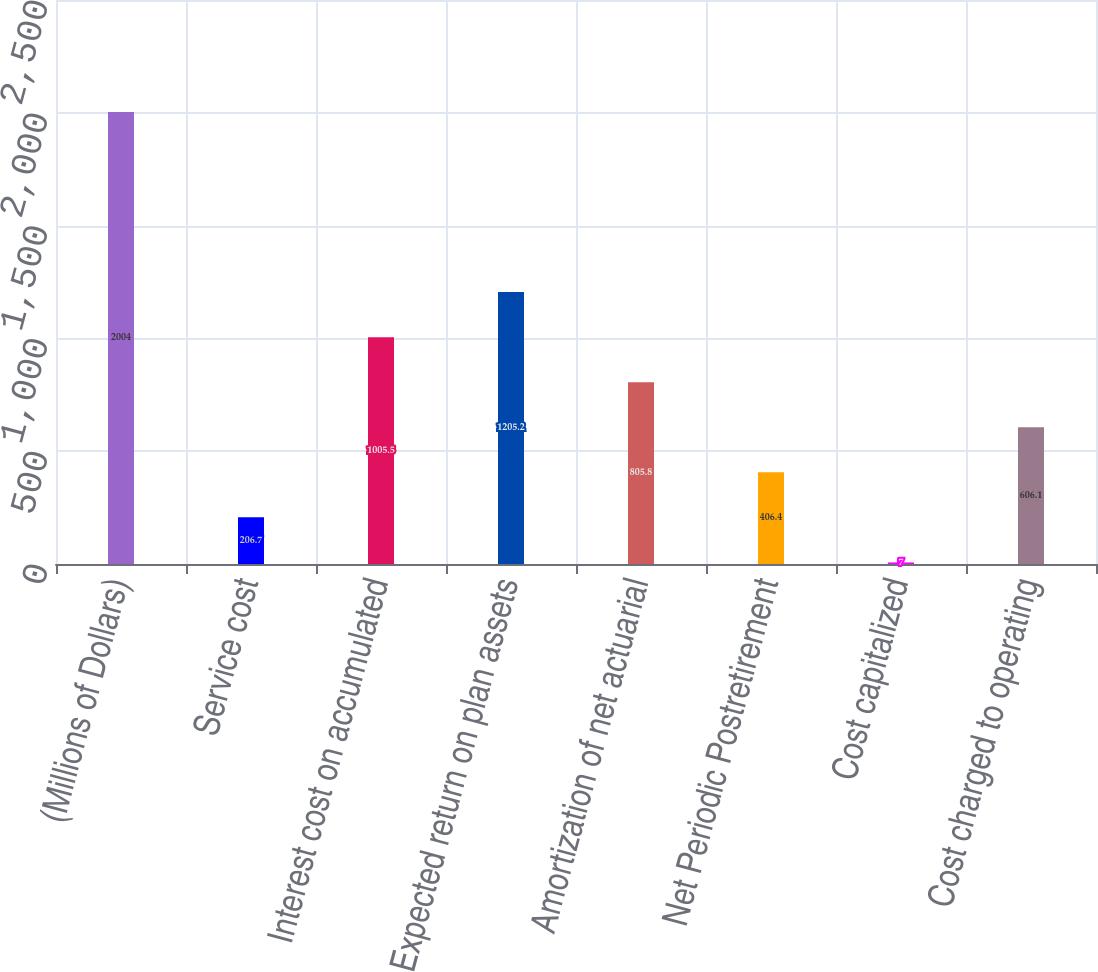<chart> <loc_0><loc_0><loc_500><loc_500><bar_chart><fcel>(Millions of Dollars)<fcel>Service cost<fcel>Interest cost on accumulated<fcel>Expected return on plan assets<fcel>Amortization of net actuarial<fcel>Net Periodic Postretirement<fcel>Cost capitalized<fcel>Cost charged to operating<nl><fcel>2004<fcel>206.7<fcel>1005.5<fcel>1205.2<fcel>805.8<fcel>406.4<fcel>7<fcel>606.1<nl></chart> 